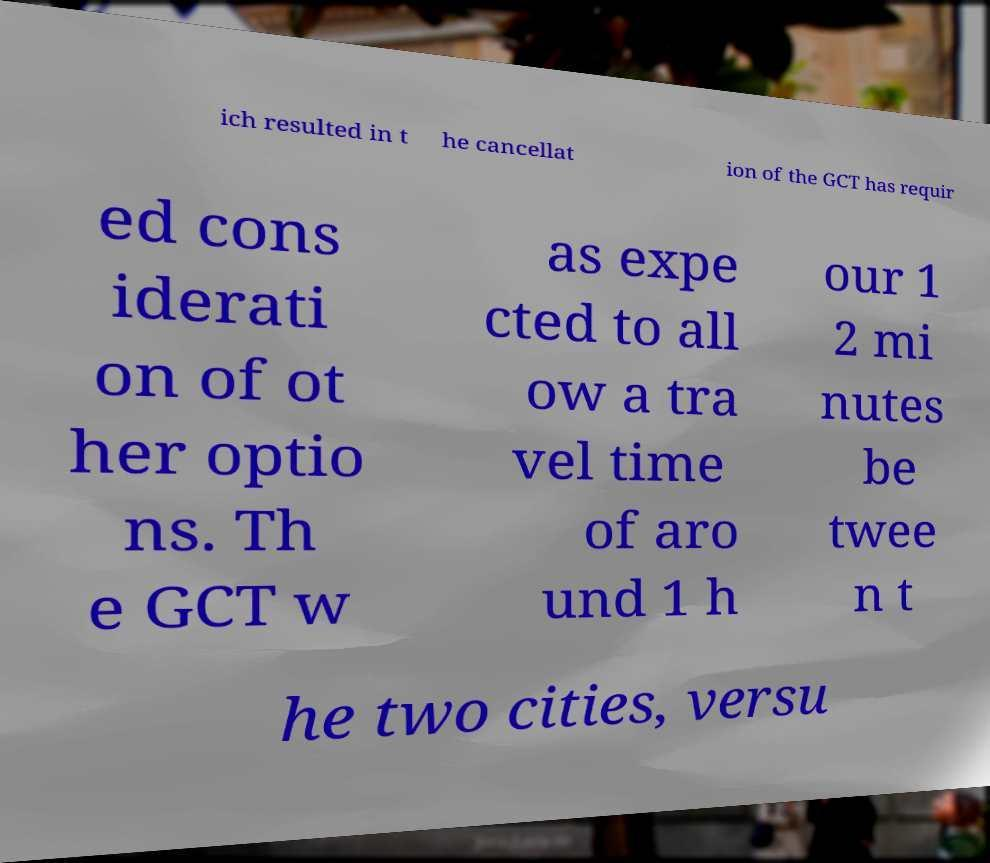Please identify and transcribe the text found in this image. ich resulted in t he cancellat ion of the GCT has requir ed cons iderati on of ot her optio ns. Th e GCT w as expe cted to all ow a tra vel time of aro und 1 h our 1 2 mi nutes be twee n t he two cities, versu 